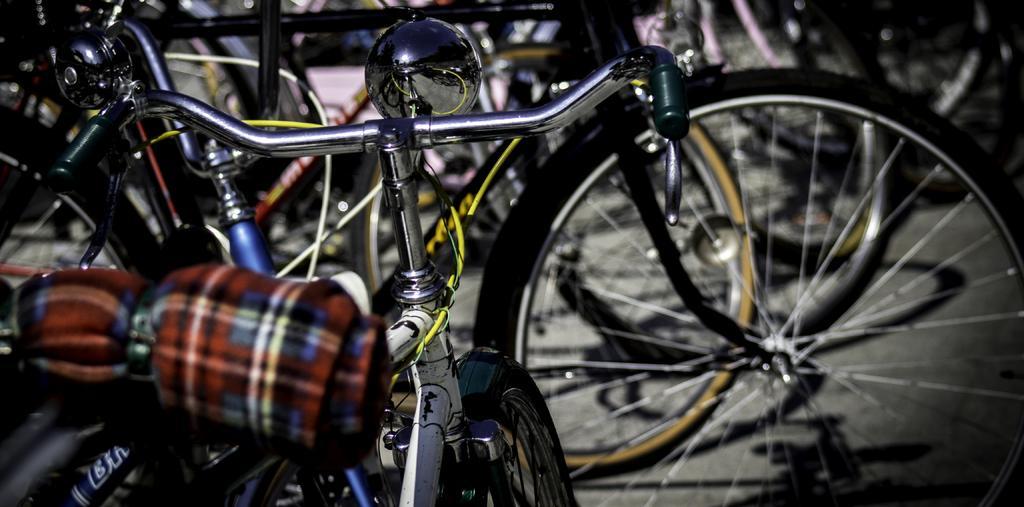Please provide a concise description of this image. In this picture we can see a few bicycles. There is a colorful object on a bicycle on the left side. 